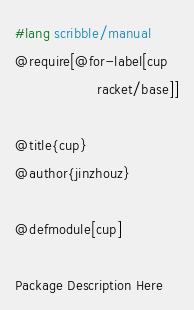Convert code to text. <code><loc_0><loc_0><loc_500><loc_500><_Racket_>#lang scribble/manual
@require[@for-label[cup
                    racket/base]]

@title{cup}
@author{jinzhouz}

@defmodule[cup]

Package Description Here
</code> 